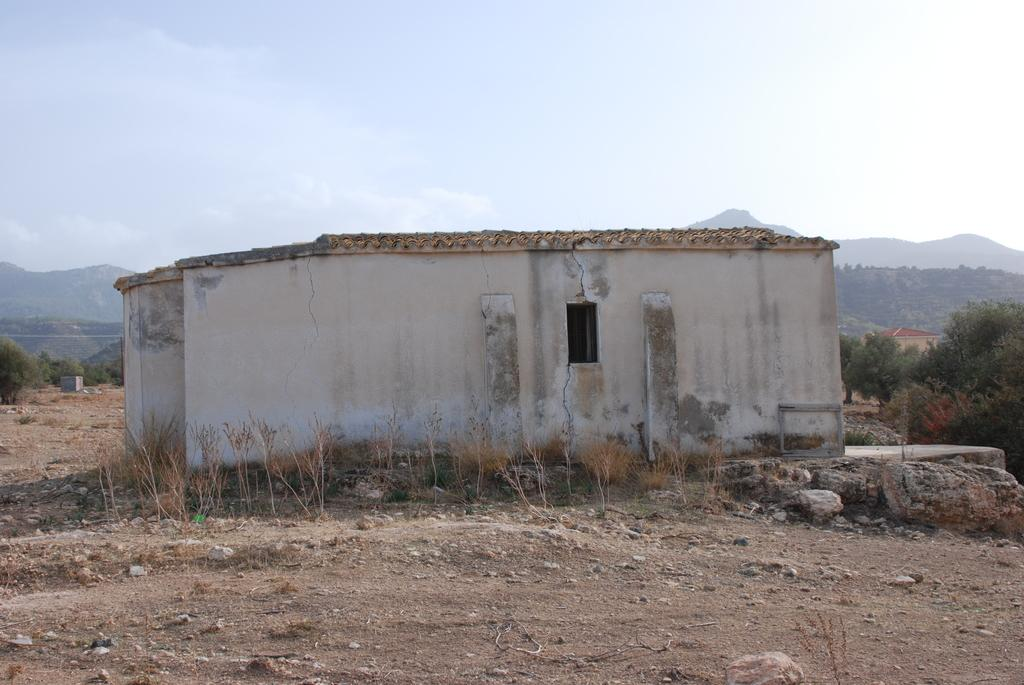What type of structure is visible in the image? There is a building in the image, which appears to be an old house. What can be seen in the background of the image? There are trees and hills visible in the background of the image. What is the weather like in the image? The sky is cloudy in the image. What type of vegetation is present on the ground in the image? There are plants on the ground in the image. Can you see a turkey attacking the old house in the image? No, there is no turkey or any attack depicted in the image. The image features an old house, trees, hills, and a cloudy sky. 